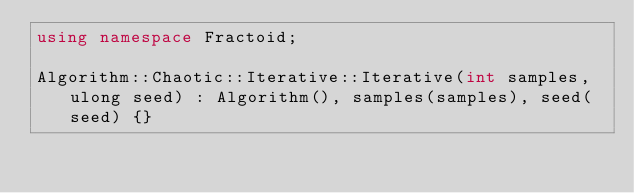Convert code to text. <code><loc_0><loc_0><loc_500><loc_500><_C++_>using namespace Fractoid;

Algorithm::Chaotic::Iterative::Iterative(int samples, ulong seed) : Algorithm(), samples(samples), seed(seed) {}
</code> 